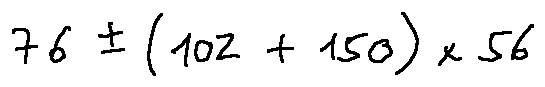Convert formula to latex. <formula><loc_0><loc_0><loc_500><loc_500>7 6 \pm ( 1 0 2 + 1 5 0 ) \times 5 6</formula> 